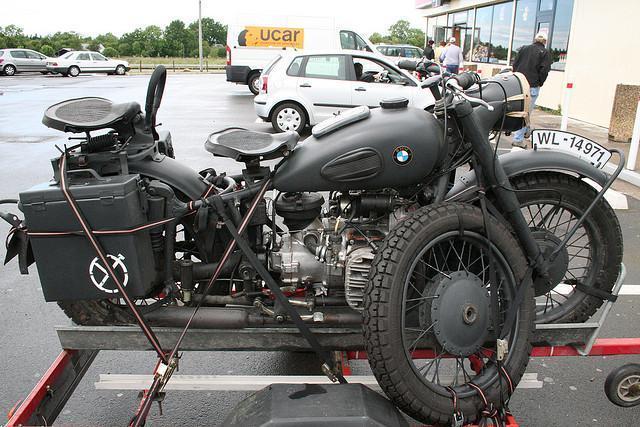How many blue trains can you see?
Give a very brief answer. 0. 